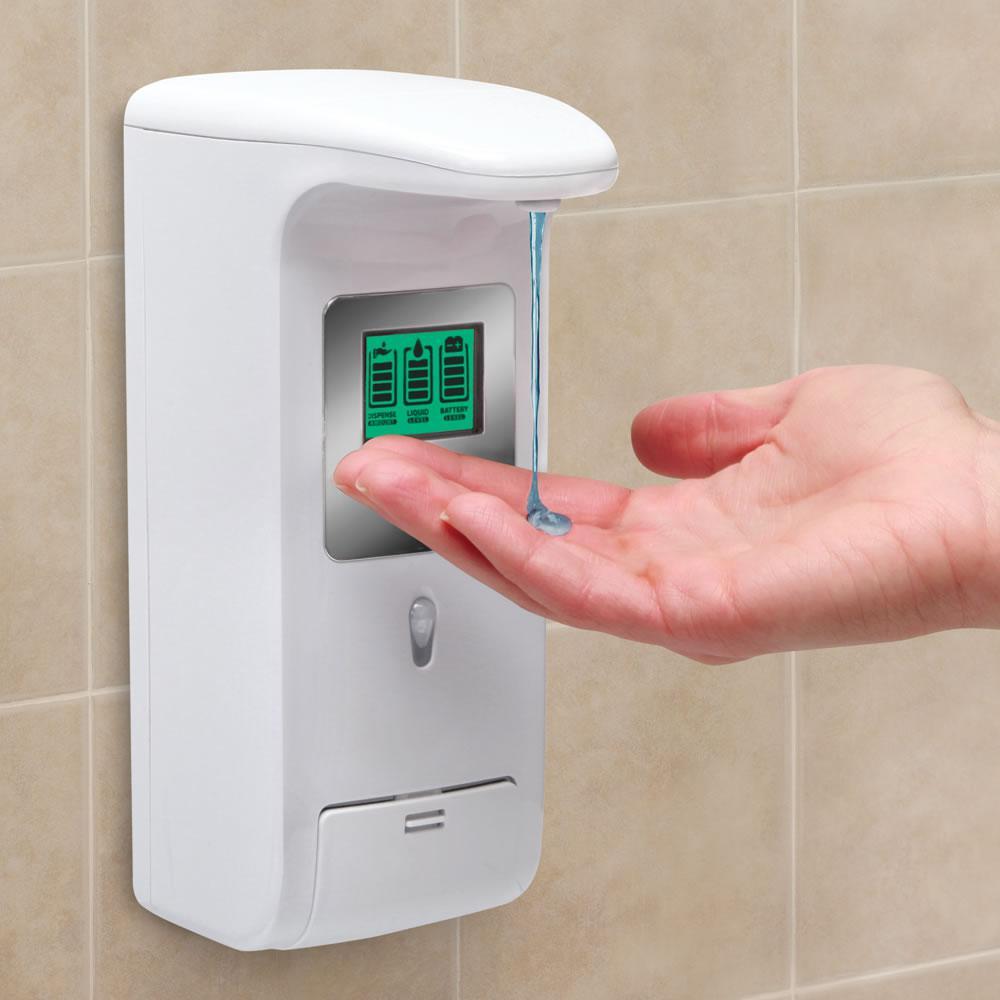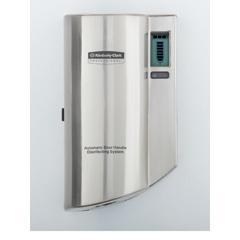The first image is the image on the left, the second image is the image on the right. Assess this claim about the two images: "In one of the images, a person's hand is visible using a soap dispenser". Correct or not? Answer yes or no. Yes. The first image is the image on the left, the second image is the image on the right. Assess this claim about the two images: "a human hand is dispensing soap". Correct or not? Answer yes or no. Yes. 